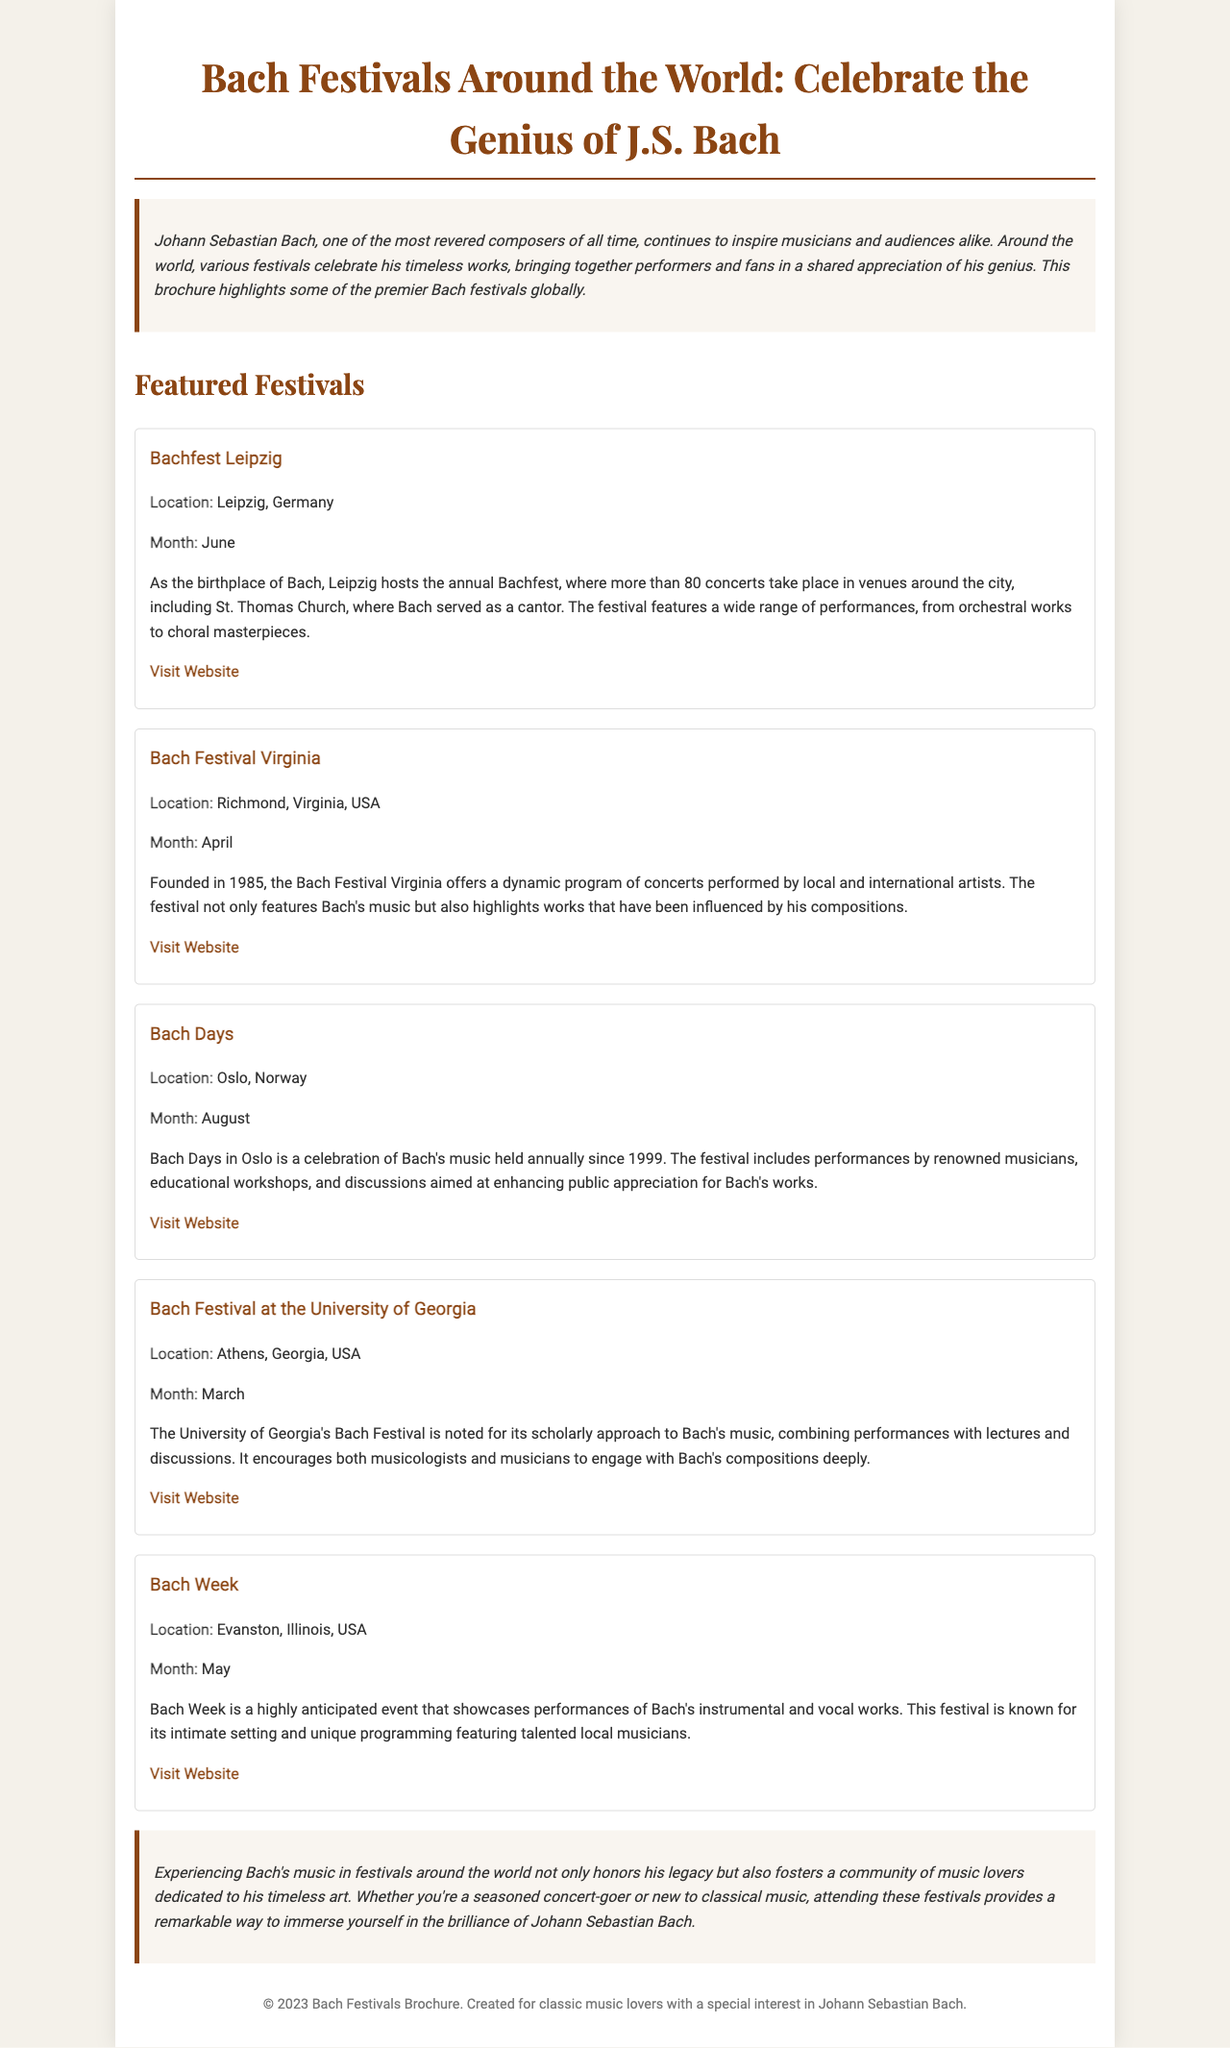What is the name of the festival that takes place in Leipzig? The document mentions Bachfest Leipzig as the festival in Leipzig.
Answer: Bachfest Leipzig In which month does the Bach Festival Virginia occur? The month of April is specified for the Bach Festival Virginia in the document.
Answer: April What location is associated with the Bach Days festival? The document states that Bach Days is held in Oslo, Norway.
Answer: Oslo, Norway How many concerts are featured in the Bachfest Leipzig? The document indicates that there are more than 80 concerts at the Bachfest Leipzig.
Answer: More than 80 Which festival emphasizes a scholarly approach to Bach's music? The document describes the Bach Festival at the University of Georgia as having a notable scholarly approach.
Answer: Bach Festival at the University of Georgia What is the main activity of the Bach Days festival in Oslo? The main activities include performances by renowned musicians, educational workshops, and discussions.
Answer: Performances, workshops, discussions What type of works are performed at Bach Week? The festival is known for showcasing Bach's instrumental and vocal works.
Answer: Instrumental and vocal works Which festival was founded in 1985? The document states that the Bach Festival Virginia was founded in 1985.
Answer: Bach Festival Virginia What is the overall purpose of attending these Bach festivals according to the document? The document emphasizes that attending these festivals honors Bach's legacy and fosters a community of music lovers.
Answer: Honor Bach's legacy, foster community 